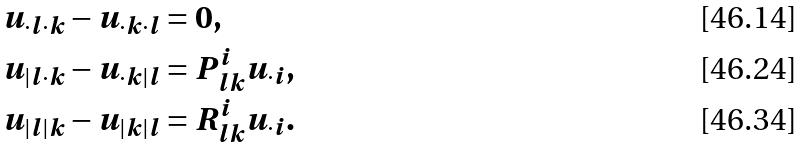<formula> <loc_0><loc_0><loc_500><loc_500>u _ { \cdot l \cdot k } - u _ { \cdot k \cdot l } & = 0 , \\ u _ { | l \cdot k } - u _ { \cdot k | l } & = P ^ { i } _ { l k } u _ { \cdot i } , \\ u _ { | l | k } - u _ { | k | l } & = R ^ { i } _ { l k } u _ { \cdot i } .</formula> 